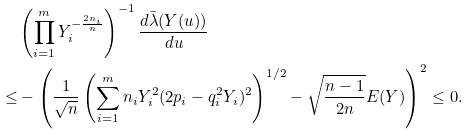<formula> <loc_0><loc_0><loc_500><loc_500>& \left ( \prod _ { i = 1 } ^ { m } Y _ { i } ^ { - \frac { 2 n _ { i } } { n } } \right ) ^ { - 1 } \frac { d \bar { \lambda } ( Y ( u ) ) } { d u } \\ \leq & - \left ( \frac { 1 } { \sqrt { n } } \left ( \sum _ { i = 1 } ^ { m } n _ { i } Y _ { i } ^ { 2 } ( 2 p _ { i } - q _ { i } ^ { 2 } Y _ { i } ) ^ { 2 } \right ) ^ { 1 / 2 } - \sqrt { \frac { n - 1 } { 2 n } } E ( Y ) \right ) ^ { 2 } \leq 0 .</formula> 